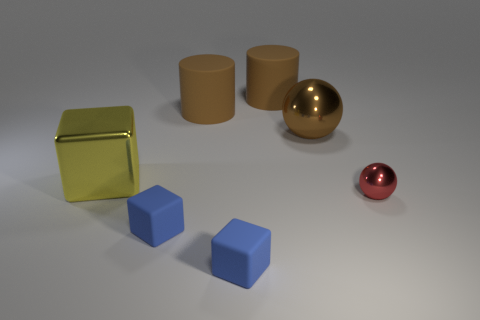Add 3 matte cubes. How many objects exist? 10 Subtract all cylinders. How many objects are left? 5 Subtract all gray things. Subtract all tiny metal spheres. How many objects are left? 6 Add 4 large rubber cylinders. How many large rubber cylinders are left? 6 Add 7 small red rubber objects. How many small red rubber objects exist? 7 Subtract 0 red blocks. How many objects are left? 7 